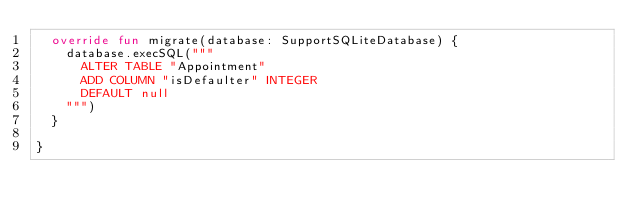Convert code to text. <code><loc_0><loc_0><loc_500><loc_500><_Kotlin_>  override fun migrate(database: SupportSQLiteDatabase) {
    database.execSQL("""
      ALTER TABLE "Appointment"
      ADD COLUMN "isDefaulter" INTEGER
      DEFAULT null
    """)
  }

}
</code> 